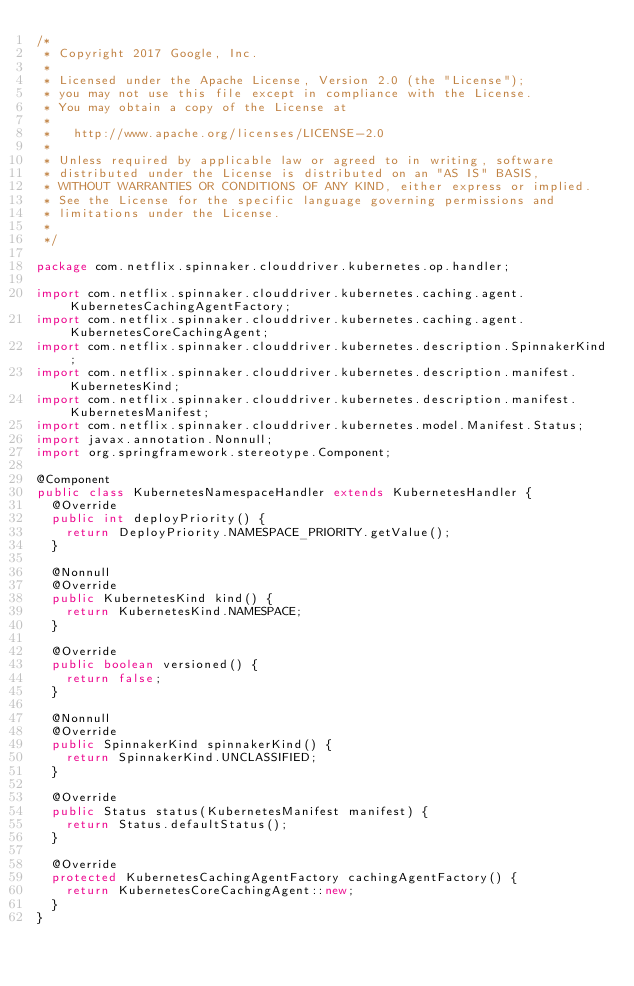Convert code to text. <code><loc_0><loc_0><loc_500><loc_500><_Java_>/*
 * Copyright 2017 Google, Inc.
 *
 * Licensed under the Apache License, Version 2.0 (the "License");
 * you may not use this file except in compliance with the License.
 * You may obtain a copy of the License at
 *
 *   http://www.apache.org/licenses/LICENSE-2.0
 *
 * Unless required by applicable law or agreed to in writing, software
 * distributed under the License is distributed on an "AS IS" BASIS,
 * WITHOUT WARRANTIES OR CONDITIONS OF ANY KIND, either express or implied.
 * See the License for the specific language governing permissions and
 * limitations under the License.
 *
 */

package com.netflix.spinnaker.clouddriver.kubernetes.op.handler;

import com.netflix.spinnaker.clouddriver.kubernetes.caching.agent.KubernetesCachingAgentFactory;
import com.netflix.spinnaker.clouddriver.kubernetes.caching.agent.KubernetesCoreCachingAgent;
import com.netflix.spinnaker.clouddriver.kubernetes.description.SpinnakerKind;
import com.netflix.spinnaker.clouddriver.kubernetes.description.manifest.KubernetesKind;
import com.netflix.spinnaker.clouddriver.kubernetes.description.manifest.KubernetesManifest;
import com.netflix.spinnaker.clouddriver.kubernetes.model.Manifest.Status;
import javax.annotation.Nonnull;
import org.springframework.stereotype.Component;

@Component
public class KubernetesNamespaceHandler extends KubernetesHandler {
  @Override
  public int deployPriority() {
    return DeployPriority.NAMESPACE_PRIORITY.getValue();
  }

  @Nonnull
  @Override
  public KubernetesKind kind() {
    return KubernetesKind.NAMESPACE;
  }

  @Override
  public boolean versioned() {
    return false;
  }

  @Nonnull
  @Override
  public SpinnakerKind spinnakerKind() {
    return SpinnakerKind.UNCLASSIFIED;
  }

  @Override
  public Status status(KubernetesManifest manifest) {
    return Status.defaultStatus();
  }

  @Override
  protected KubernetesCachingAgentFactory cachingAgentFactory() {
    return KubernetesCoreCachingAgent::new;
  }
}
</code> 